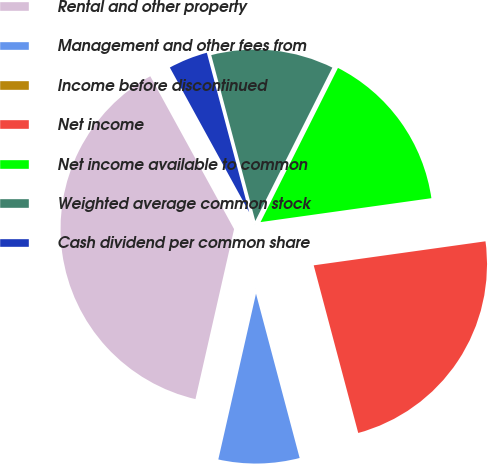Convert chart. <chart><loc_0><loc_0><loc_500><loc_500><pie_chart><fcel>Rental and other property<fcel>Management and other fees from<fcel>Income before discontinued<fcel>Net income<fcel>Net income available to common<fcel>Weighted average common stock<fcel>Cash dividend per common share<nl><fcel>38.46%<fcel>7.69%<fcel>0.0%<fcel>23.08%<fcel>15.38%<fcel>11.54%<fcel>3.85%<nl></chart> 